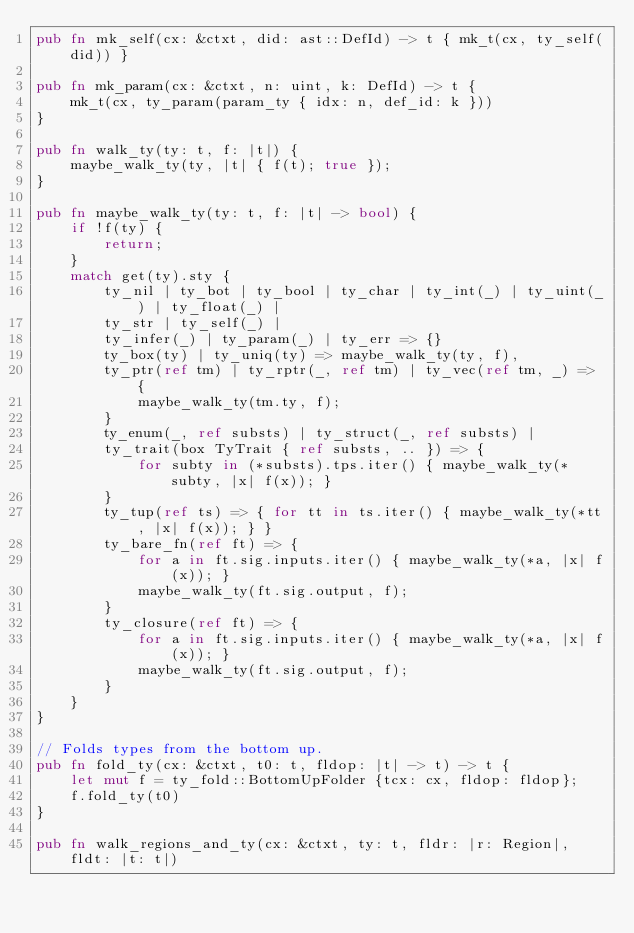<code> <loc_0><loc_0><loc_500><loc_500><_Rust_>pub fn mk_self(cx: &ctxt, did: ast::DefId) -> t { mk_t(cx, ty_self(did)) }

pub fn mk_param(cx: &ctxt, n: uint, k: DefId) -> t {
    mk_t(cx, ty_param(param_ty { idx: n, def_id: k }))
}

pub fn walk_ty(ty: t, f: |t|) {
    maybe_walk_ty(ty, |t| { f(t); true });
}

pub fn maybe_walk_ty(ty: t, f: |t| -> bool) {
    if !f(ty) {
        return;
    }
    match get(ty).sty {
        ty_nil | ty_bot | ty_bool | ty_char | ty_int(_) | ty_uint(_) | ty_float(_) |
        ty_str | ty_self(_) |
        ty_infer(_) | ty_param(_) | ty_err => {}
        ty_box(ty) | ty_uniq(ty) => maybe_walk_ty(ty, f),
        ty_ptr(ref tm) | ty_rptr(_, ref tm) | ty_vec(ref tm, _) => {
            maybe_walk_ty(tm.ty, f);
        }
        ty_enum(_, ref substs) | ty_struct(_, ref substs) |
        ty_trait(box TyTrait { ref substs, .. }) => {
            for subty in (*substs).tps.iter() { maybe_walk_ty(*subty, |x| f(x)); }
        }
        ty_tup(ref ts) => { for tt in ts.iter() { maybe_walk_ty(*tt, |x| f(x)); } }
        ty_bare_fn(ref ft) => {
            for a in ft.sig.inputs.iter() { maybe_walk_ty(*a, |x| f(x)); }
            maybe_walk_ty(ft.sig.output, f);
        }
        ty_closure(ref ft) => {
            for a in ft.sig.inputs.iter() { maybe_walk_ty(*a, |x| f(x)); }
            maybe_walk_ty(ft.sig.output, f);
        }
    }
}

// Folds types from the bottom up.
pub fn fold_ty(cx: &ctxt, t0: t, fldop: |t| -> t) -> t {
    let mut f = ty_fold::BottomUpFolder {tcx: cx, fldop: fldop};
    f.fold_ty(t0)
}

pub fn walk_regions_and_ty(cx: &ctxt, ty: t, fldr: |r: Region|, fldt: |t: t|)</code> 